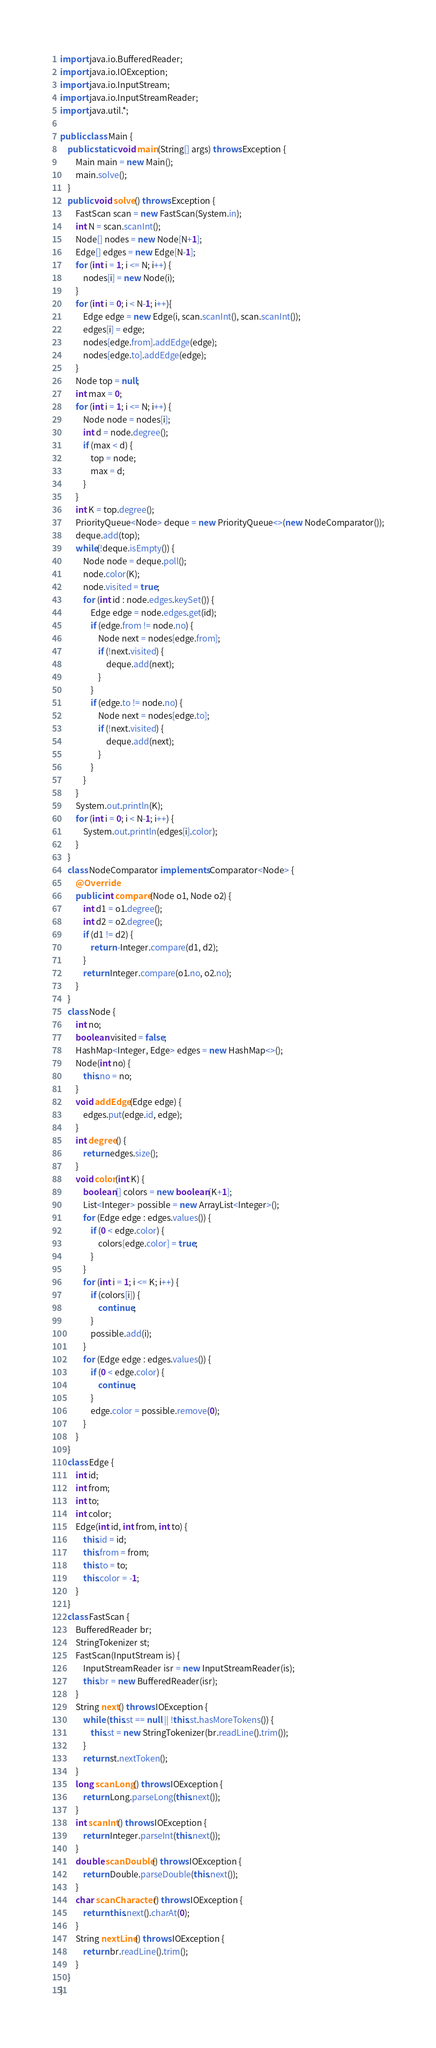<code> <loc_0><loc_0><loc_500><loc_500><_Java_>import java.io.BufferedReader;
import java.io.IOException;
import java.io.InputStream;
import java.io.InputStreamReader;
import java.util.*;

public class Main {
    public static void main(String[] args) throws Exception {
        Main main = new Main();
        main.solve();
    }
    public void solve() throws Exception {
        FastScan scan = new FastScan(System.in);
        int N = scan.scanInt();
        Node[] nodes = new Node[N+1];
        Edge[] edges = new Edge[N-1];
        for (int i = 1; i <= N; i++) {
            nodes[i] = new Node(i);
        }
        for (int i = 0; i < N-1; i++){
            Edge edge = new Edge(i, scan.scanInt(), scan.scanInt());
            edges[i] = edge;
            nodes[edge.from].addEdge(edge);
            nodes[edge.to].addEdge(edge);
        }
        Node top = null;
        int max = 0;
        for (int i = 1; i <= N; i++) {
            Node node = nodes[i];
            int d = node.degree();
            if (max < d) {
                top = node;
                max = d;
            }
        }
        int K = top.degree();
        PriorityQueue<Node> deque = new PriorityQueue<>(new NodeComparator());
        deque.add(top);
        while(!deque.isEmpty()) {
            Node node = deque.poll();
            node.color(K);
            node.visited = true;
            for (int id : node.edges.keySet()) {
                Edge edge = node.edges.get(id);
                if (edge.from != node.no) {
                    Node next = nodes[edge.from];
                    if (!next.visited) {
                        deque.add(next);
                    }
                }
                if (edge.to != node.no) {
                    Node next = nodes[edge.to];
                    if (!next.visited) {
                        deque.add(next);
                    }
                }
            }
        }
        System.out.println(K);
        for (int i = 0; i < N-1; i++) {
            System.out.println(edges[i].color);
        }
    }
    class NodeComparator implements Comparator<Node> {
        @Override
        public int compare(Node o1, Node o2) {
            int d1 = o1.degree();
            int d2 = o2.degree();
            if (d1 != d2) {
                return -Integer.compare(d1, d2);
            }
            return Integer.compare(o1.no, o2.no);
        }
    }
    class Node {
        int no;
        boolean visited = false;
        HashMap<Integer, Edge> edges = new HashMap<>();
        Node(int no) {
            this.no = no;
        }
        void addEdge(Edge edge) {
            edges.put(edge.id, edge);
        }
        int degree() {
            return edges.size();
        }
        void color(int K) {
            boolean[] colors = new boolean[K+1];
            List<Integer> possible = new ArrayList<Integer>();
            for (Edge edge : edges.values()) {
                if (0 < edge.color) {
                    colors[edge.color] = true;
                }
            }
            for (int i = 1; i <= K; i++) {
                if (colors[i]) {
                    continue;
                }
                possible.add(i);
            }
            for (Edge edge : edges.values()) {
                if (0 < edge.color) {
                    continue;
                }
                edge.color = possible.remove(0);
            }
        }
    }
    class Edge {
        int id;
        int from;
        int to;
        int color;
        Edge(int id, int from, int to) {
            this.id = id;
            this.from = from;
            this.to = to;
            this.color = -1;
        }
    }
    class FastScan {
        BufferedReader br;
        StringTokenizer st;
        FastScan(InputStream is) {
            InputStreamReader isr = new InputStreamReader(is);
            this.br = new BufferedReader(isr);
        }
        String next() throws IOException {
            while (this.st == null || !this.st.hasMoreTokens()) {
                this.st = new StringTokenizer(br.readLine().trim());
            }
            return st.nextToken();
        }
        long scanLong() throws IOException {
            return Long.parseLong(this.next());
        }
        int scanInt() throws IOException {
            return Integer.parseInt(this.next());
        }
        double scanDouble() throws IOException {
            return Double.parseDouble(this.next());
        }
        char scanCharacter() throws IOException {
            return this.next().charAt(0);
        }
        String nextLine() throws IOException {
            return br.readLine().trim();
        }
    }
}
</code> 